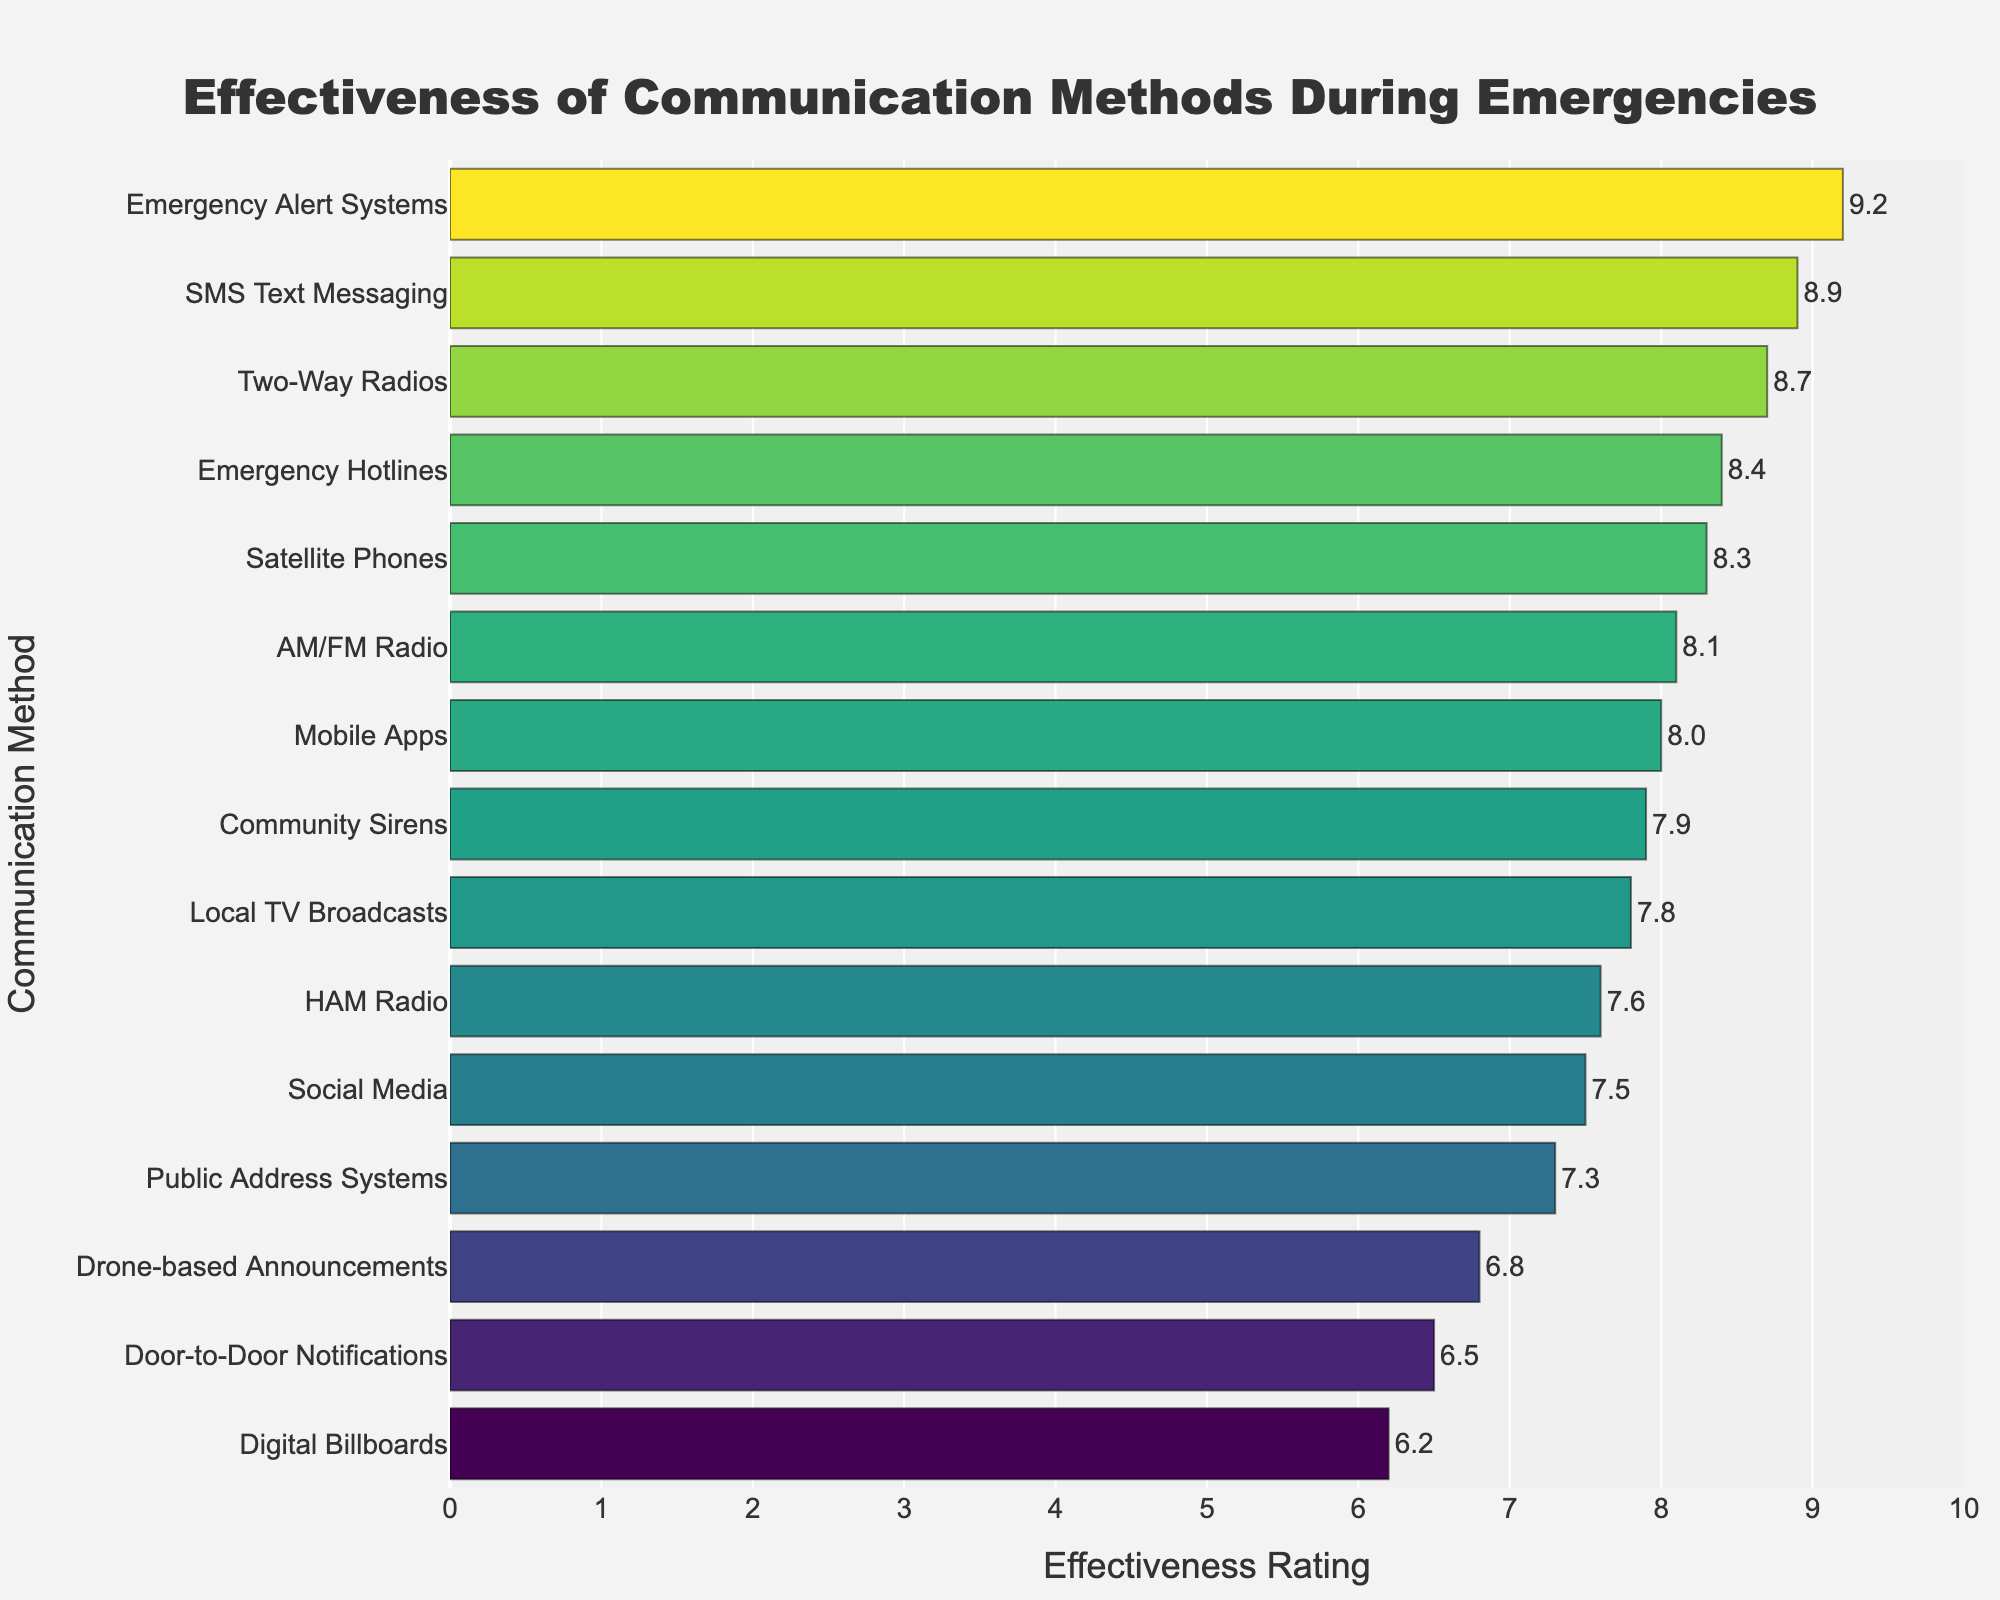What is the most effective communication method during emergencies according to the chart? We need to look for the highest bar in the chart and identify the communication method it represents. The tallest bar corresponds to "Emergency Alert Systems" with an effectiveness rating of 9.2.
Answer: Emergency Alert Systems Which communication method has the lowest effectiveness rating? Identify the shortest bar in the chart, which corresponds to "Digital Billboards" with an effectiveness rating of 6.2.
Answer: Digital Billboards How much more effective are Emergency Alert Systems compared to Door-to-Door Notifications? Subtract the effectiveness rating of Door-to-Door Notifications (6.5) from Emergency Alert Systems (9.2). The difference is 9.2 - 6.5 = 2.7.
Answer: 2.7 Which two communication methods have an equal effectiveness rating and what is that rating? Identify bars of the same height and read their labels. "Mobile Apps" and "AM/FM Radio" both have an effectiveness rating of 8.
Answer: Mobile Apps and AM/FM Radio Arrange the following communication methods in descending order of their effectiveness: Social Media, Two-Way Radios, Satellite Phones, Emergency Hotlines. Compare the effectiveness ratings of these methods. Emergency Hotlines (8.4), Two-Way Radios (8.7), Satellite Phones (8.3), Social Media (7.5). In descending order: Two-Way Radios, Emergency Hotlines, Satellite Phones, Social Media.
Answer: Two-Way Radios, Emergency Hotlines, Satellite Phones, Social Media What is the average effectiveness rating of SMS Text Messaging, Satellite Phones, and HAM Radio? Add the ratings together and divide by the number of methods. (8.9 + 8.3 + 7.6) / 3 = 24.8 / 3 = 8.27.
Answer: 8.27 What is the difference in effectiveness between the least effective and most effective communication methods? Subtract the lowest effectiveness rating (Digital Billboards, 6.2) from the highest (Emergency Alert Systems, 9.2). The difference is 9.2 - 6.2 = 3.
Answer: 3 Which communication method has a higher effectiveness rating: Social Media or Drone-based Announcements? Compare the effectiveness ratings of Social Media (7.5) and Drone-based Announcements (6.8). Social Media has a higher rating.
Answer: Social Media How many communication methods have an effectiveness rating of 8.0 or higher? Count the number of methods with effectiveness ratings of 8.0 or above by checking each bar's value. There are nine methods: Emergency Alert Systems, Two-Way Radios, SMS Text Messaging, Satellite Phones, Local TV Broadcasts, AM/FM Radio, Emergency Hotlines, and Community Sirens.
Answer: Nine What is the median effectiveness rating from the chart? Arrange all effectiveness ratings in ascending order and identify the middle value or the average of the two middle values. Ordered ratings: 6.2, 6.5, 6.8, 7.3, 7.5, 7.6, 7.8, 7.9, 8.0, 8.1, 8.3, 8.4, 8.7, 8.9, 9.2. The median is the 8th value: 7.9.
Answer: 7.9 